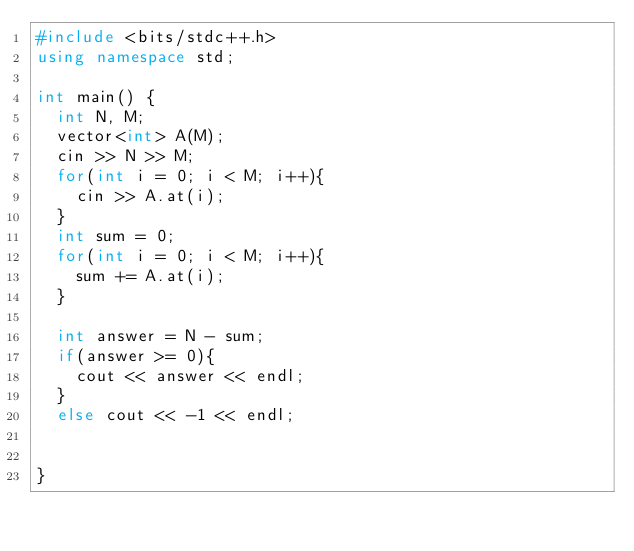<code> <loc_0><loc_0><loc_500><loc_500><_C++_>#include <bits/stdc++.h>
using namespace std;

int main() {
  int N, M;
  vector<int> A(M);
  cin >> N >> M;
  for(int i = 0; i < M; i++){
    cin >> A.at(i);
  }
  int sum = 0;
  for(int i = 0; i < M; i++){
    sum += A.at(i);
  }
  
  int answer = N - sum;
  if(answer >= 0){
	cout << answer << endl;
  }
  else cout << -1 << endl;
  
  
}</code> 